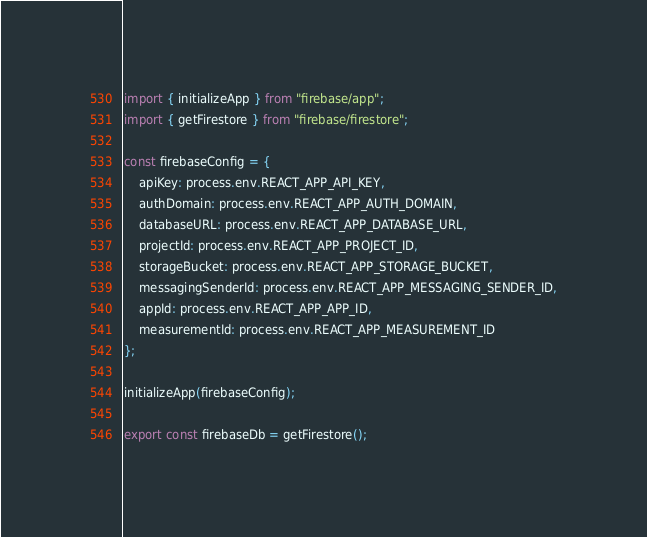<code> <loc_0><loc_0><loc_500><loc_500><_JavaScript_>import { initializeApp } from "firebase/app";
import { getFirestore } from "firebase/firestore";

const firebaseConfig = {
    apiKey: process.env.REACT_APP_API_KEY,
    authDomain: process.env.REACT_APP_AUTH_DOMAIN,
    databaseURL: process.env.REACT_APP_DATABASE_URL,
    projectId: process.env.REACT_APP_PROJECT_ID,
    storageBucket: process.env.REACT_APP_STORAGE_BUCKET,
    messagingSenderId: process.env.REACT_APP_MESSAGING_SENDER_ID,
    appId: process.env.REACT_APP_APP_ID,
    measurementId: process.env.REACT_APP_MEASUREMENT_ID
};

initializeApp(firebaseConfig);

export const firebaseDb = getFirestore();</code> 